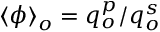Convert formula to latex. <formula><loc_0><loc_0><loc_500><loc_500>\langle \phi \rangle _ { o } = q _ { o } ^ { p } / q _ { o } ^ { s }</formula> 